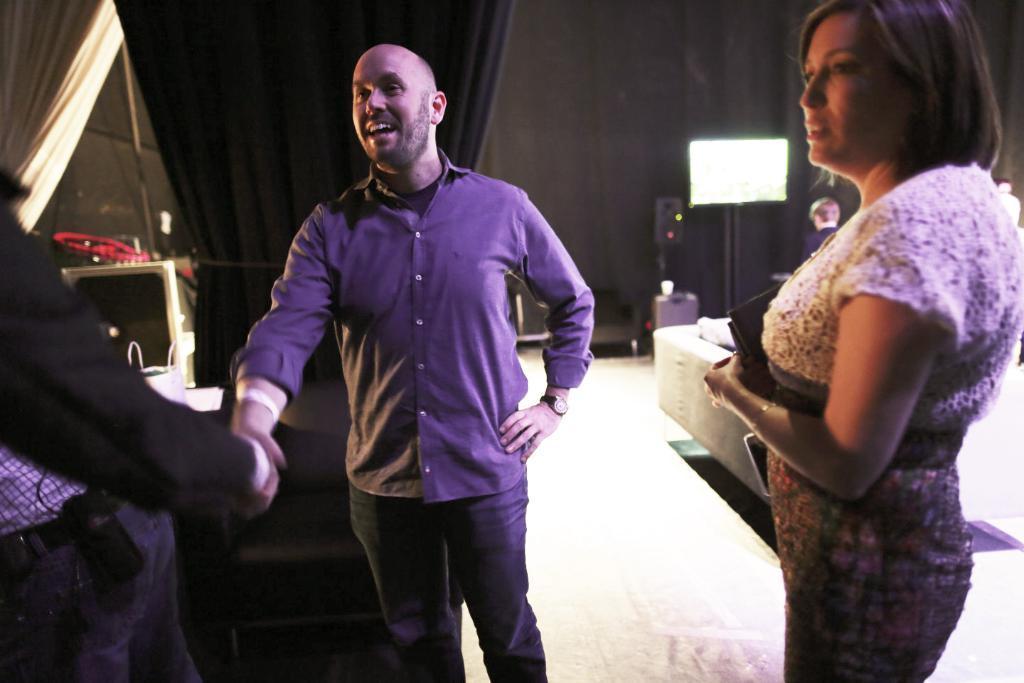Describe this image in one or two sentences. In this image we can see people. Here we can see floor, couch, curtains, screen, wall, and few objects. 